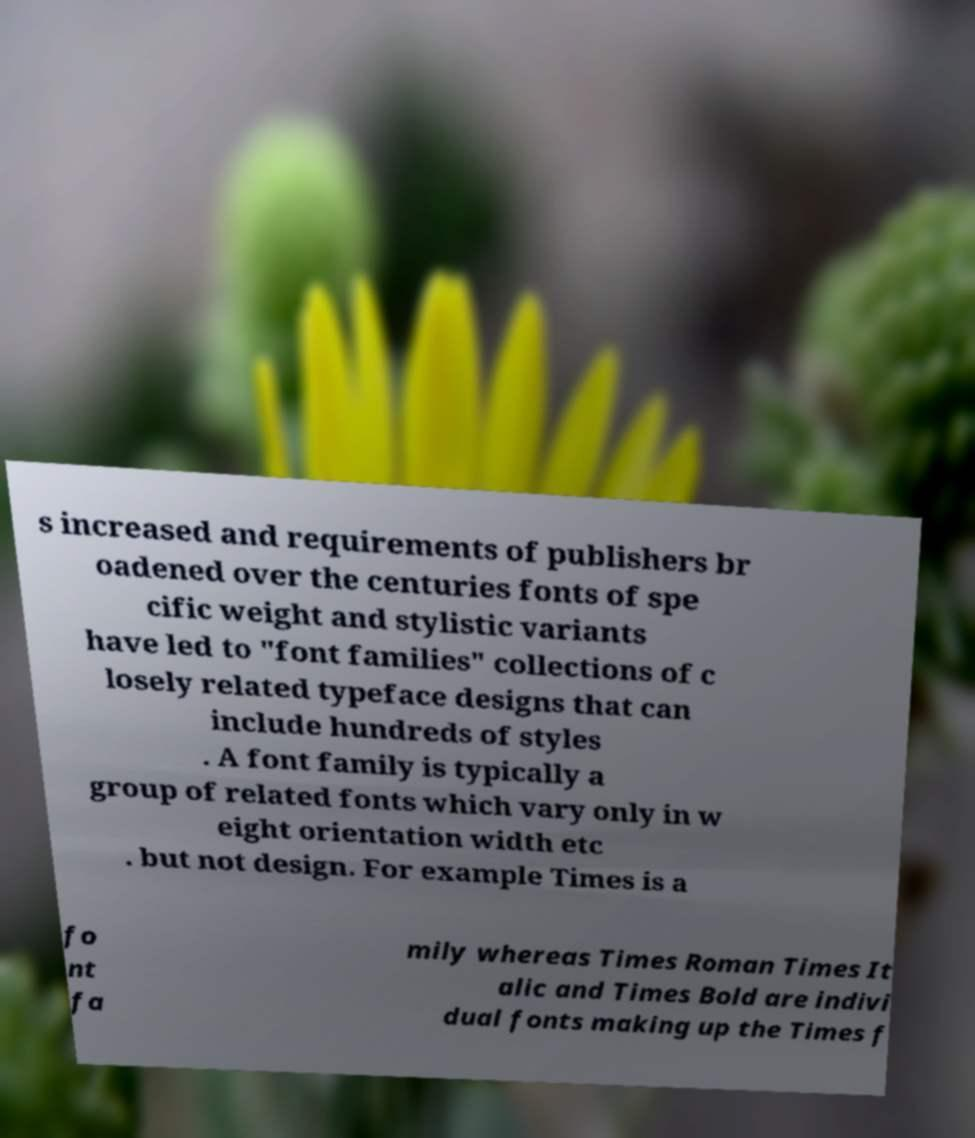Could you assist in decoding the text presented in this image and type it out clearly? s increased and requirements of publishers br oadened over the centuries fonts of spe cific weight and stylistic variants have led to "font families" collections of c losely related typeface designs that can include hundreds of styles . A font family is typically a group of related fonts which vary only in w eight orientation width etc . but not design. For example Times is a fo nt fa mily whereas Times Roman Times It alic and Times Bold are indivi dual fonts making up the Times f 